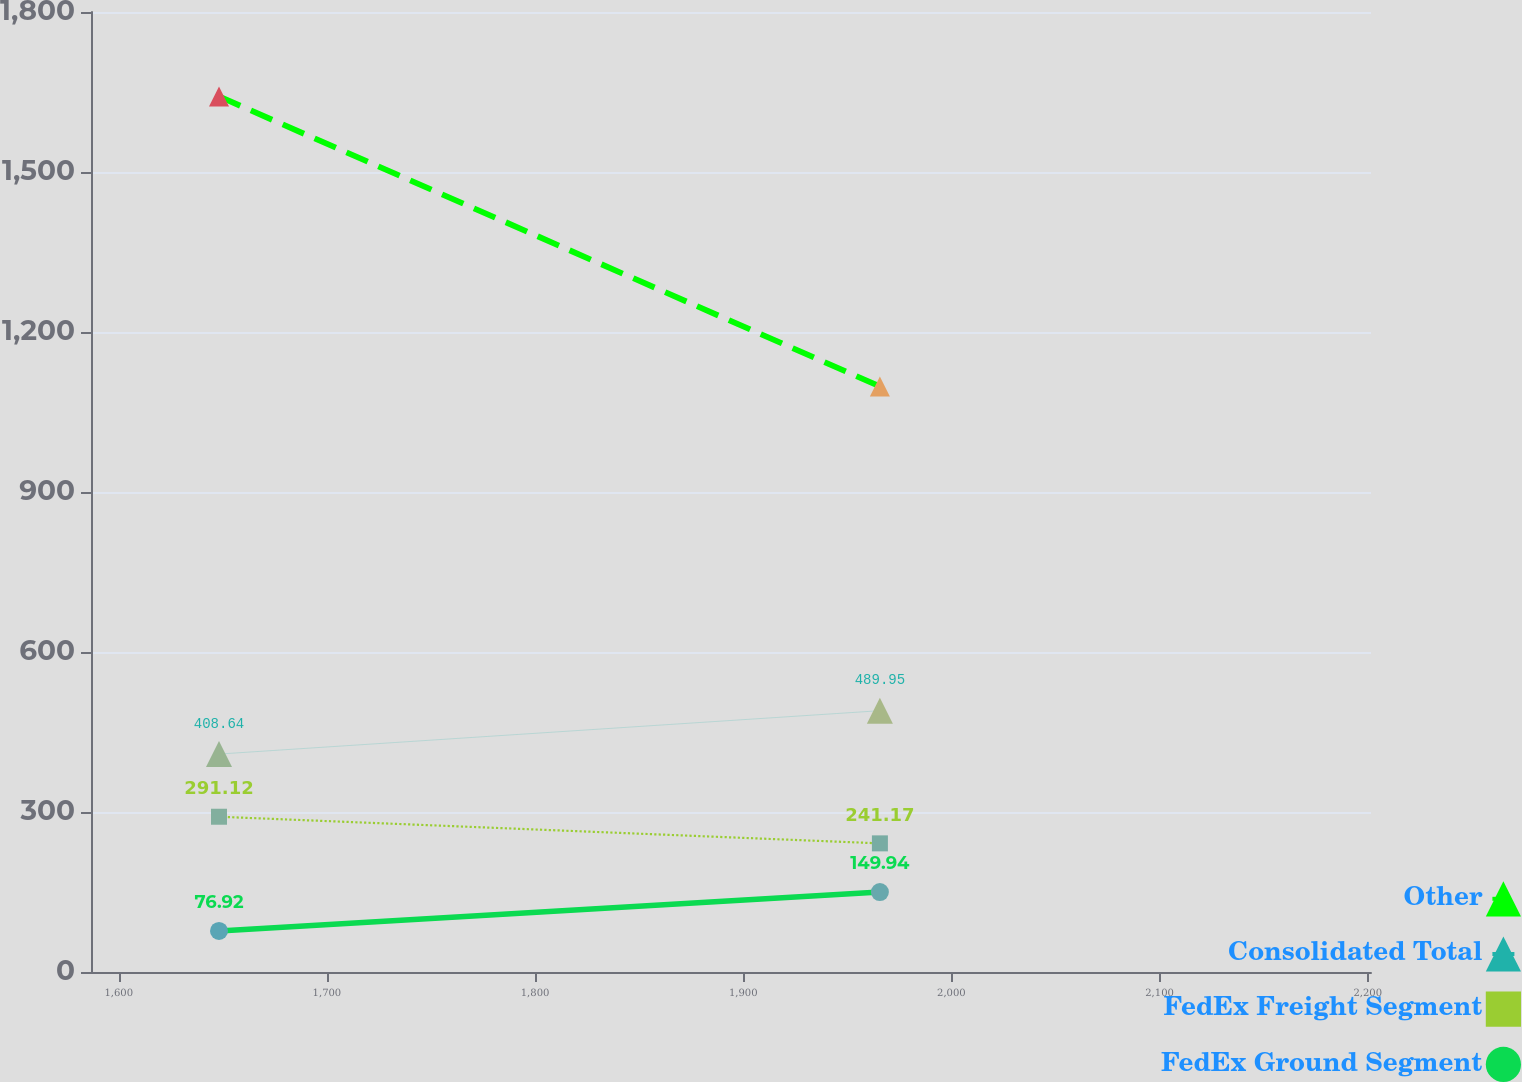Convert chart to OTSL. <chart><loc_0><loc_0><loc_500><loc_500><line_chart><ecel><fcel>Other<fcel>Consolidated Total<fcel>FedEx Freight Segment<fcel>FedEx Ground Segment<nl><fcel>1648.16<fcel>1641.66<fcel>408.64<fcel>291.12<fcel>76.92<nl><fcel>1965.66<fcel>1098<fcel>489.95<fcel>241.17<fcel>149.94<nl><fcel>2263.08<fcel>580.55<fcel>365.77<fcel>128.41<fcel>29.32<nl></chart> 